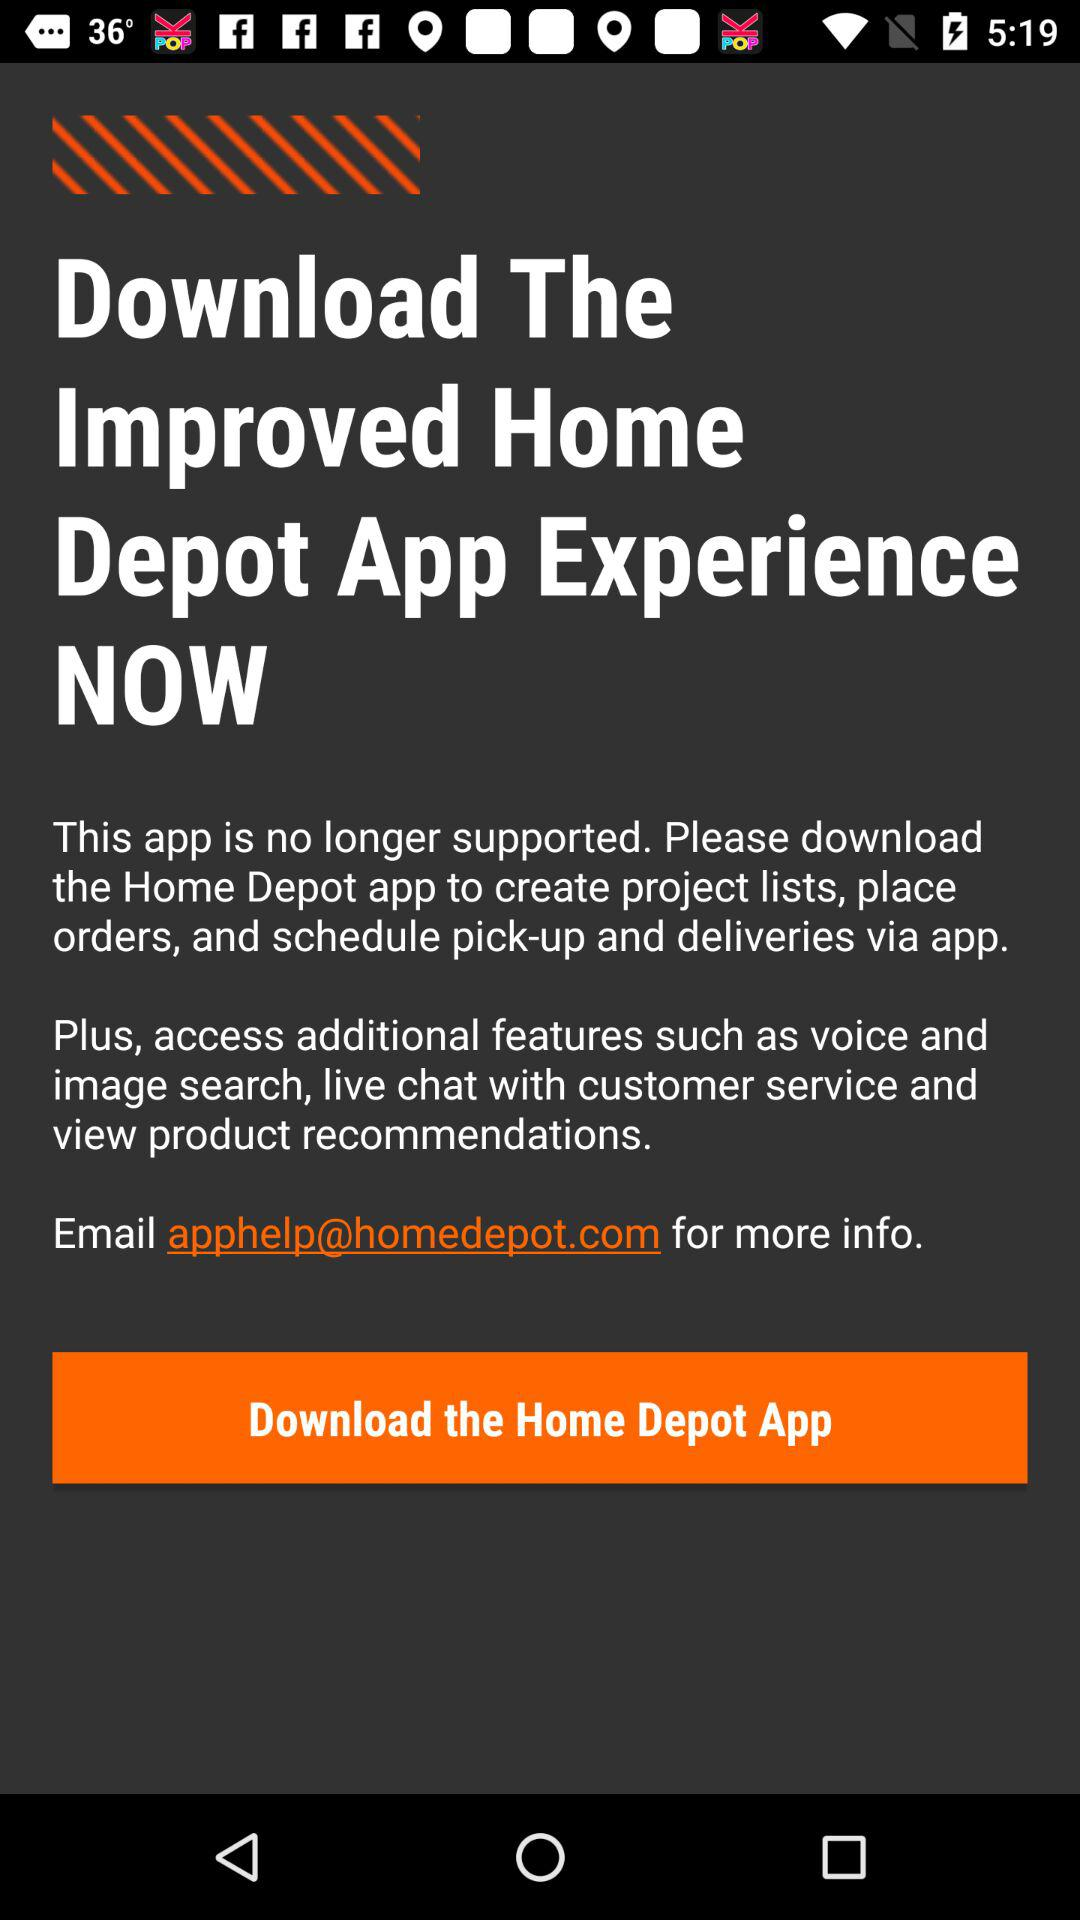What is the version of this application?
When the provided information is insufficient, respond with <no answer>. <no answer> 